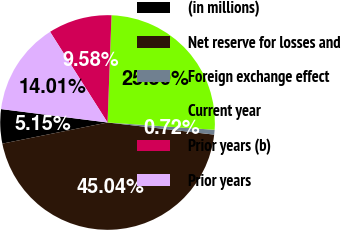<chart> <loc_0><loc_0><loc_500><loc_500><pie_chart><fcel>(in millions)<fcel>Net reserve for losses and<fcel>Foreign exchange effect<fcel>Current year<fcel>Prior years (b)<fcel>Prior years<nl><fcel>5.15%<fcel>45.03%<fcel>0.72%<fcel>25.49%<fcel>9.58%<fcel>14.01%<nl></chart> 